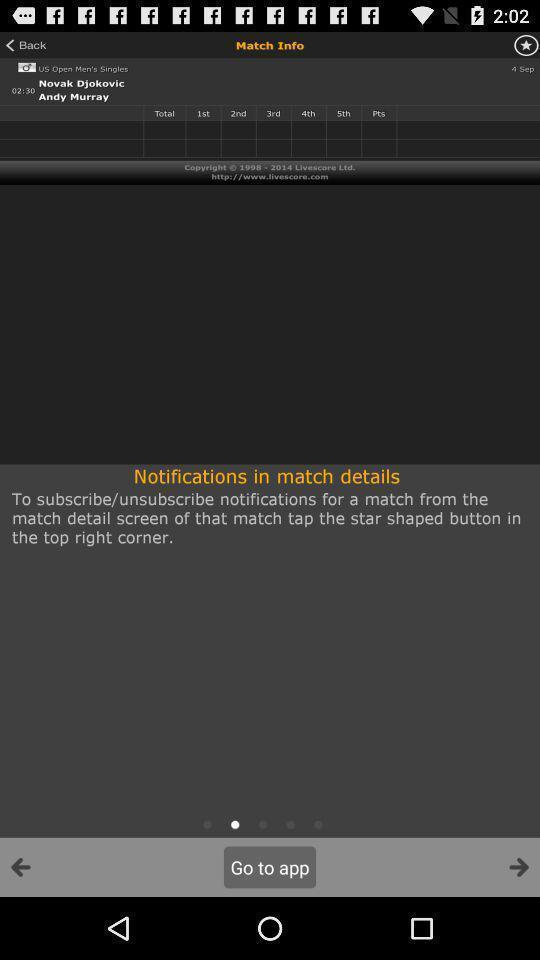Provide a detailed account of this screenshot. Page displaying notification in match details. 